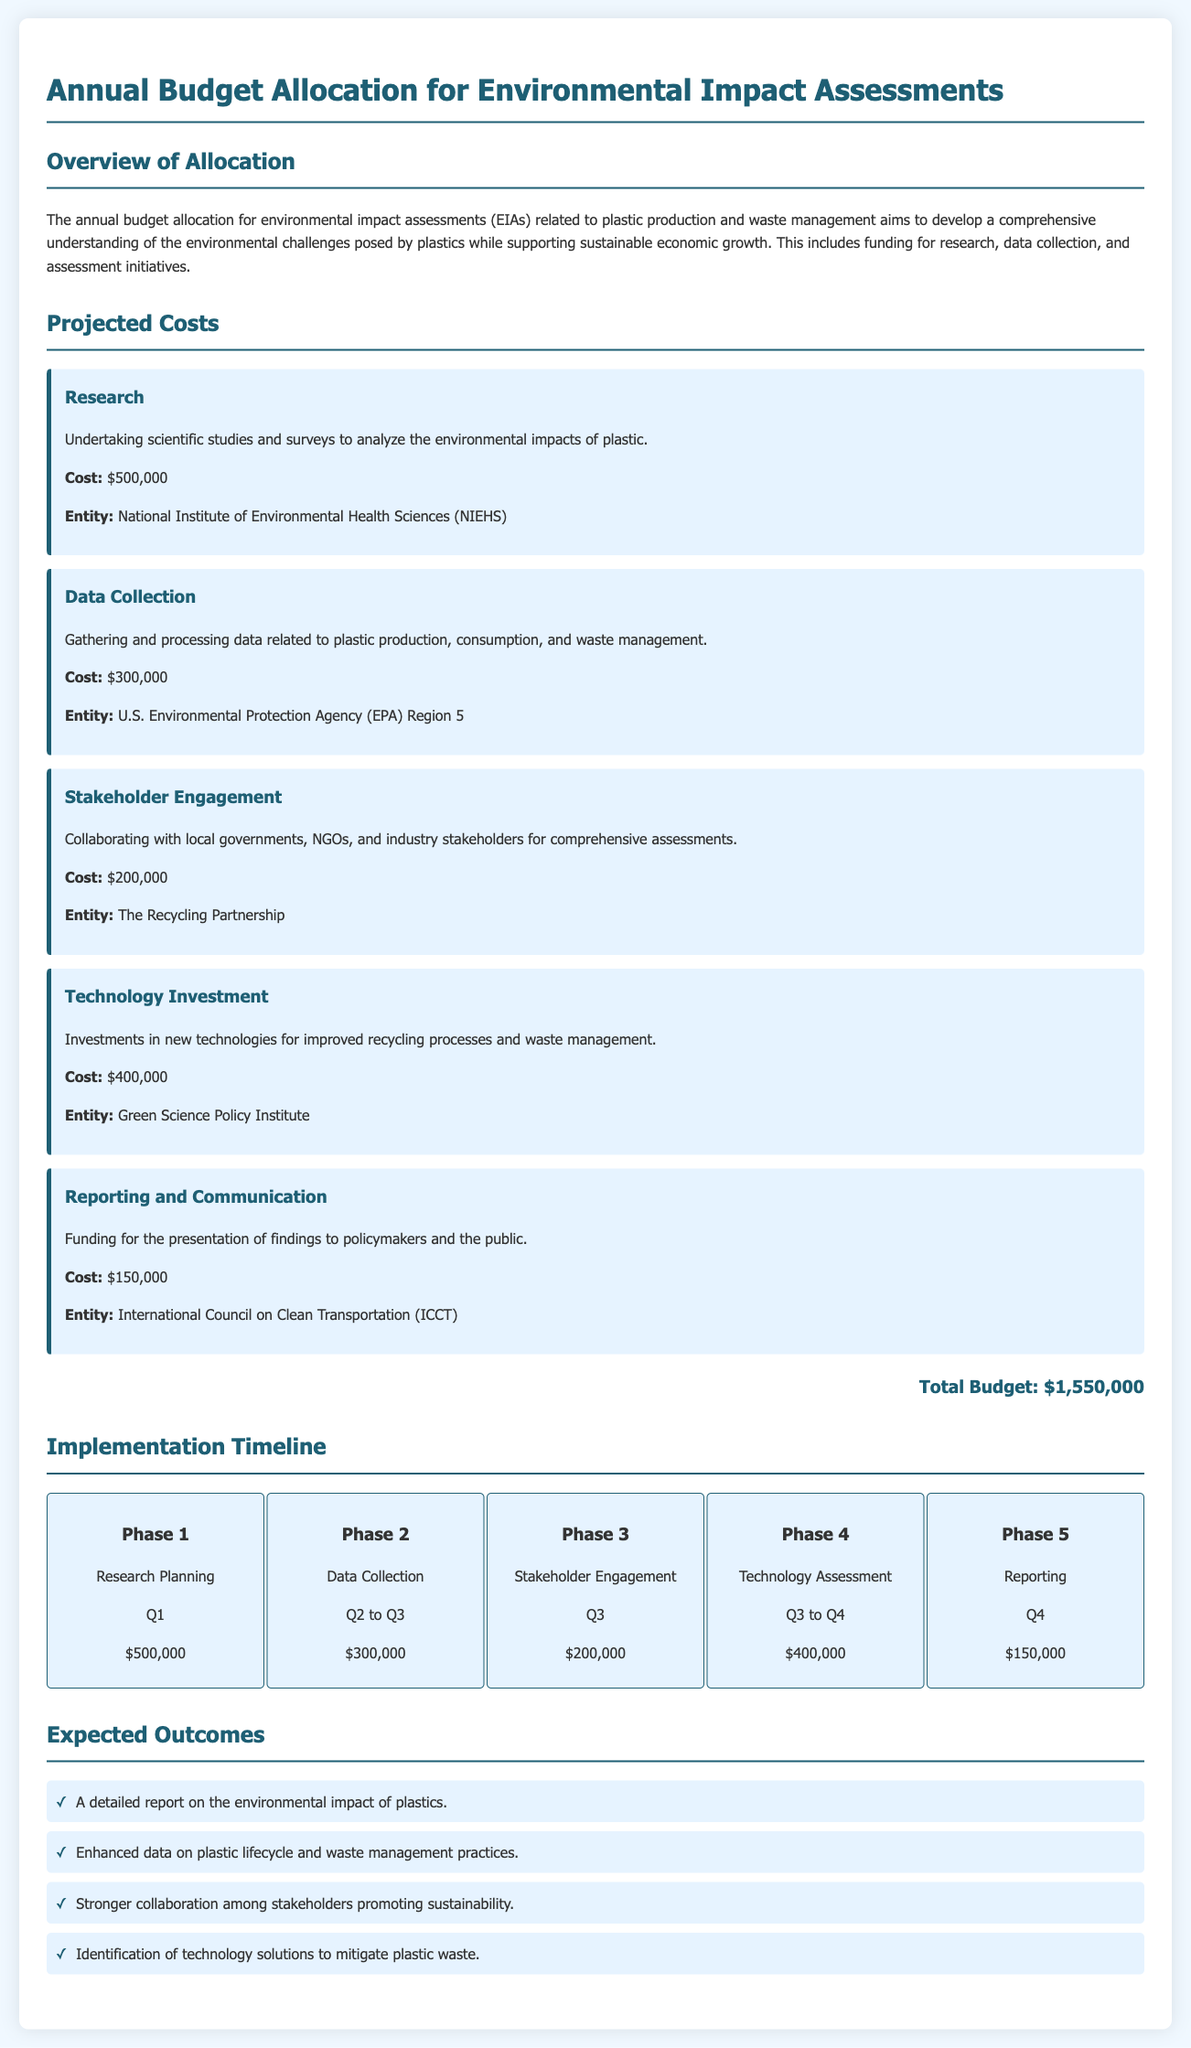what is the total budget? The total budget is provided at the end of the projected costs section, which sums all allocations for various activities.
Answer: $1,550,000 who is responsible for the research? The entity responsible for research is mentioned in the projected costs section related to the research item.
Answer: National Institute of Environmental Health Sciences (NIEHS) what is the cost allocated for stakeholder engagement? The cost for stakeholder engagement is specified in the projected costs under that specific section.
Answer: $200,000 which phase consists of data collection? The implementation timeline lists phases by activities, identifying which phase corresponds to data collection.
Answer: Phase 2 how many phases are outlined in the implementation timeline? The implementation timeline lists the number of phases for the project from planning to reporting.
Answer: 5 what is the cost for technology investment? The amount designated for technology investment is detailed in the projected costs section.
Answer: $400,000 in which quarter does reporting occur? The phase for reporting details the corresponding quarter for when this activity will take place.
Answer: Q4 what is one expected outcome from the budget allocation? The expected outcomes section lists detailed results projected from the budget allocation, citing specific anticipations.
Answer: A detailed report on the environmental impact of plastics 